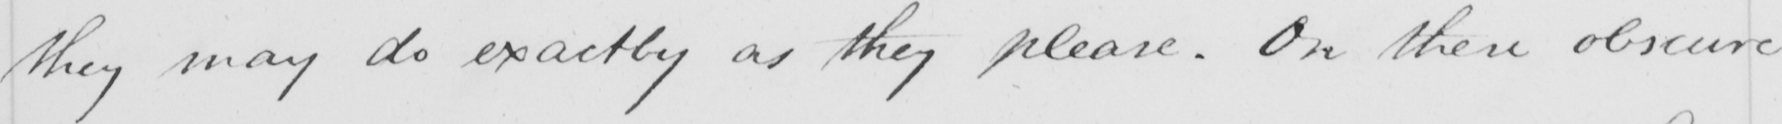What does this handwritten line say? they may do exactly as they please . On these obscure 